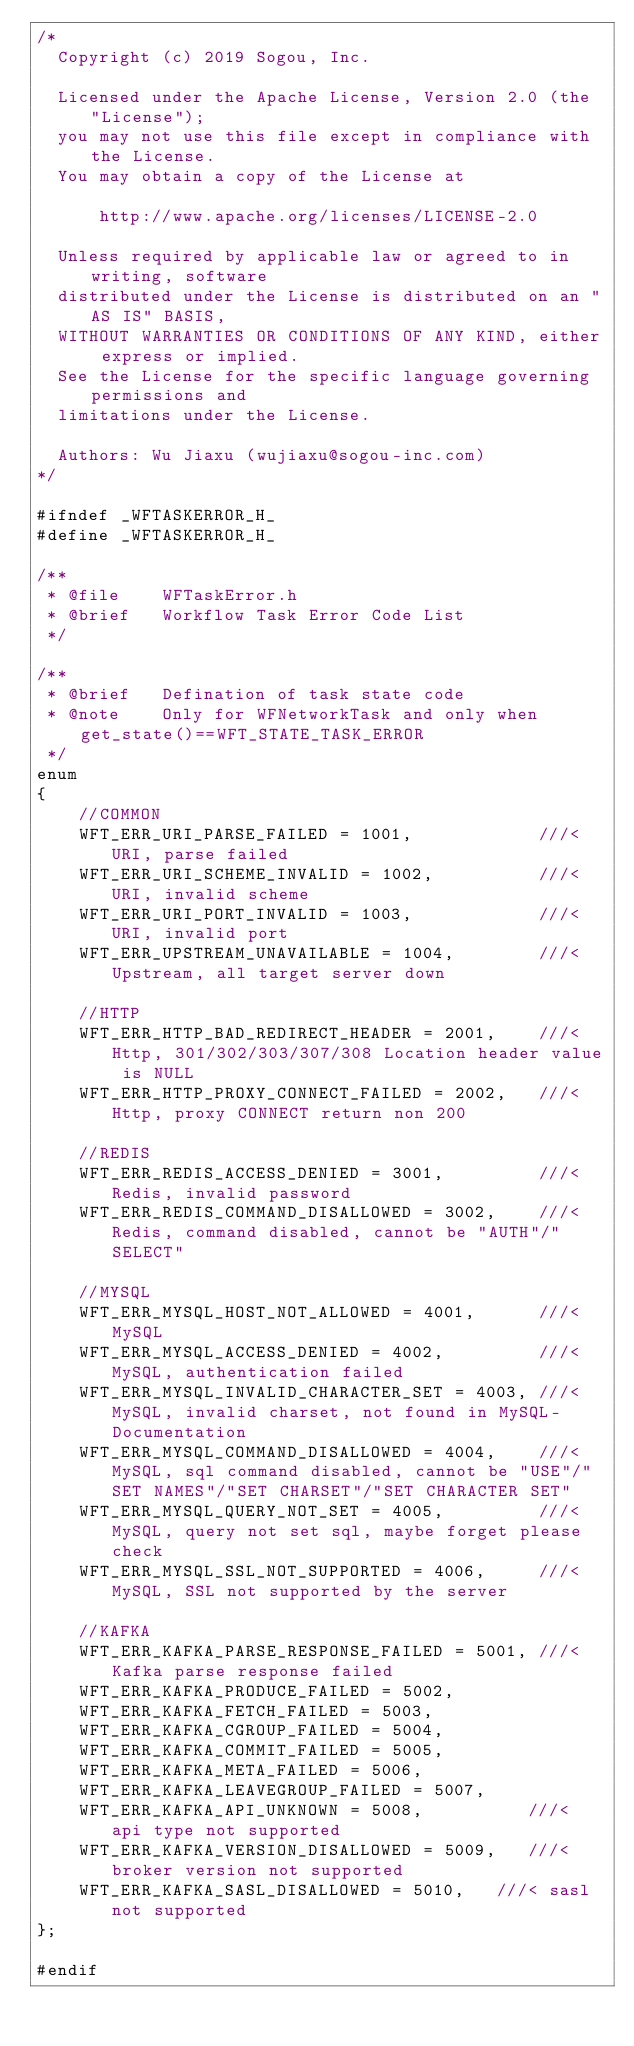Convert code to text. <code><loc_0><loc_0><loc_500><loc_500><_C_>/*
  Copyright (c) 2019 Sogou, Inc.

  Licensed under the Apache License, Version 2.0 (the "License");
  you may not use this file except in compliance with the License.
  You may obtain a copy of the License at

      http://www.apache.org/licenses/LICENSE-2.0

  Unless required by applicable law or agreed to in writing, software
  distributed under the License is distributed on an "AS IS" BASIS,
  WITHOUT WARRANTIES OR CONDITIONS OF ANY KIND, either express or implied.
  See the License for the specific language governing permissions and
  limitations under the License.

  Authors: Wu Jiaxu (wujiaxu@sogou-inc.com)
*/

#ifndef _WFTASKERROR_H_
#define _WFTASKERROR_H_

/**
 * @file    WFTaskError.h
 * @brief   Workflow Task Error Code List
 */

/**
 * @brief   Defination of task state code
 * @note    Only for WFNetworkTask and only when get_state()==WFT_STATE_TASK_ERROR
 */
enum
{
	//COMMON
	WFT_ERR_URI_PARSE_FAILED = 1001,            ///< URI, parse failed
	WFT_ERR_URI_SCHEME_INVALID = 1002,          ///< URI, invalid scheme
	WFT_ERR_URI_PORT_INVALID = 1003,            ///< URI, invalid port
	WFT_ERR_UPSTREAM_UNAVAILABLE = 1004,        ///< Upstream, all target server down

	//HTTP
	WFT_ERR_HTTP_BAD_REDIRECT_HEADER = 2001,    ///< Http, 301/302/303/307/308 Location header value is NULL
	WFT_ERR_HTTP_PROXY_CONNECT_FAILED = 2002,   ///< Http, proxy CONNECT return non 200

	//REDIS
	WFT_ERR_REDIS_ACCESS_DENIED = 3001,         ///< Redis, invalid password
	WFT_ERR_REDIS_COMMAND_DISALLOWED = 3002,    ///< Redis, command disabled, cannot be "AUTH"/"SELECT"

	//MYSQL
	WFT_ERR_MYSQL_HOST_NOT_ALLOWED = 4001,      ///< MySQL
	WFT_ERR_MYSQL_ACCESS_DENIED = 4002,         ///< MySQL, authentication failed
	WFT_ERR_MYSQL_INVALID_CHARACTER_SET = 4003, ///< MySQL, invalid charset, not found in MySQL-Documentation
	WFT_ERR_MYSQL_COMMAND_DISALLOWED = 4004,    ///< MySQL, sql command disabled, cannot be "USE"/"SET NAMES"/"SET CHARSET"/"SET CHARACTER SET"
	WFT_ERR_MYSQL_QUERY_NOT_SET = 4005,         ///< MySQL, query not set sql, maybe forget please check
	WFT_ERR_MYSQL_SSL_NOT_SUPPORTED = 4006,		///< MySQL, SSL not supported by the server

	//KAFKA
	WFT_ERR_KAFKA_PARSE_RESPONSE_FAILED = 5001, ///< Kafka parse response failed
	WFT_ERR_KAFKA_PRODUCE_FAILED = 5002,
	WFT_ERR_KAFKA_FETCH_FAILED = 5003,
	WFT_ERR_KAFKA_CGROUP_FAILED = 5004,
	WFT_ERR_KAFKA_COMMIT_FAILED = 5005,
	WFT_ERR_KAFKA_META_FAILED = 5006,
	WFT_ERR_KAFKA_LEAVEGROUP_FAILED = 5007,
	WFT_ERR_KAFKA_API_UNKNOWN = 5008,		   ///< api type not supported
	WFT_ERR_KAFKA_VERSION_DISALLOWED = 5009,   ///< broker version not supported
	WFT_ERR_KAFKA_SASL_DISALLOWED = 5010,   ///< sasl not supported
};

#endif
</code> 